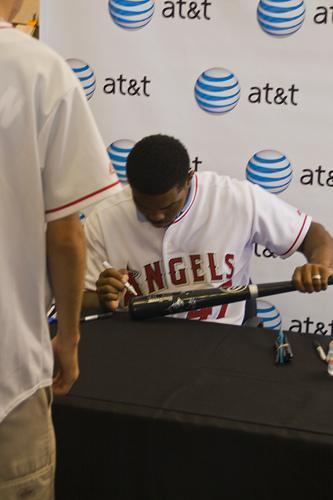What is the seated man's profession?
Pick the correct solution from the four options below to address the question.
Options: Athlete, dentist, teacher, doctor. Athlete. 